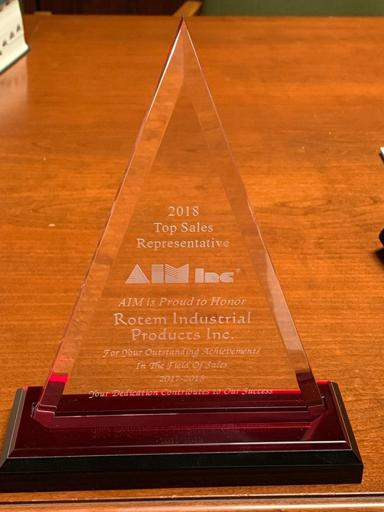What details can you infer about the event or ceremony where this award was given? Considering the professional and sleek design of the award, it's likely that the award was presented at a formal event or ceremony. Such occasions are typically reserved for recognizing significant accomplishments and fostering networking among industry peers. The ceremony would have been an opportunity to highlight the achievements of top performers like Rotem Industrial Products Inc. and to celebrate successes within the industry. Might there be any significant symbolism in the design of the award? Absolutely, the triangular form of the award is often associated with stability and aspiration, as it points upwards towards success. The clarity of the glass could symbolize transparency and purity of purpose in business practices, while the sturdy red base may represent a solid foundation or the passion for the industry that Rotem Industrial Products Inc. has demonstrated. 